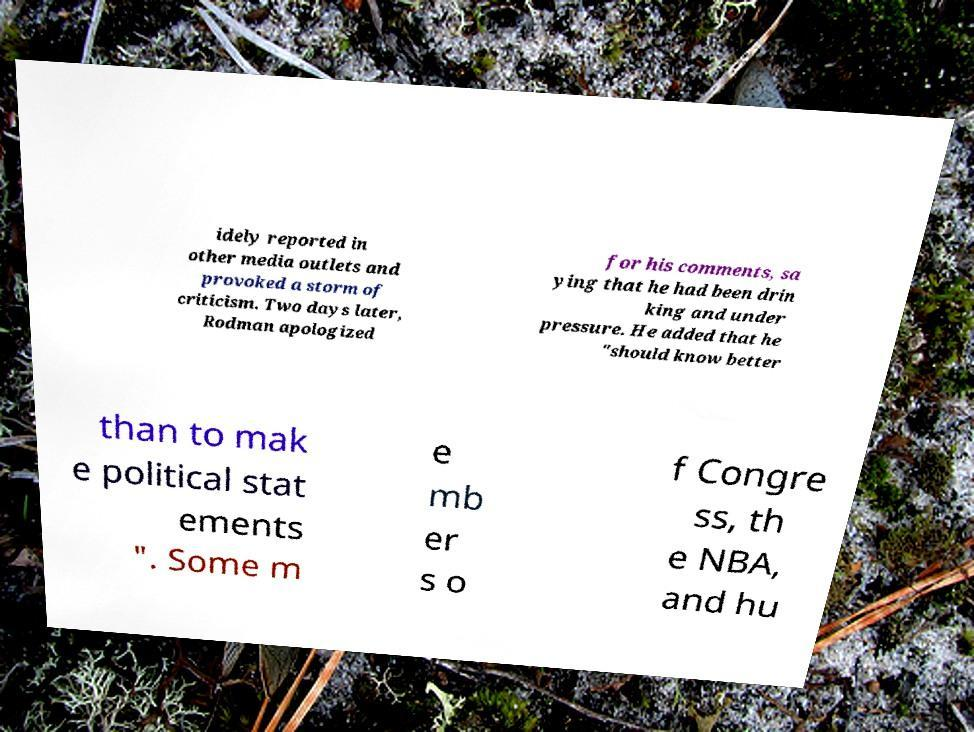What messages or text are displayed in this image? I need them in a readable, typed format. idely reported in other media outlets and provoked a storm of criticism. Two days later, Rodman apologized for his comments, sa ying that he had been drin king and under pressure. He added that he "should know better than to mak e political stat ements ". Some m e mb er s o f Congre ss, th e NBA, and hu 